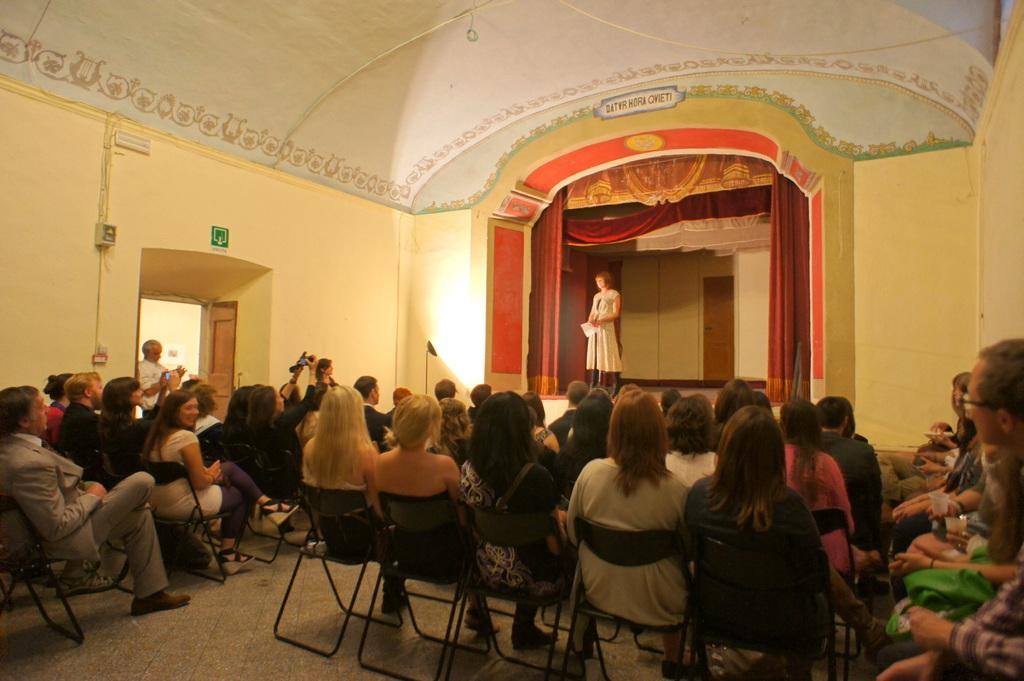What are the people in the image doing? There are many persons sitting on chairs, suggesting they are attending an event or gathering. What is happening on the stage? A lady is standing on the stage, possibly performing or addressing the audience. What is the purpose of the curtain on the stage? The curtain on the stage may be used for theatrical purposes, such as revealing or hiding performers or props. How can people enter the area where the chairs are located? There is an entrance on the left side, which people can use to enter the area. What can be seen on the walls in the image? There are pipes on the walls, which may be part of the building's infrastructure or for ventilation purposes. How much money is being thrown in the air by the lady on the stage? There is no indication in the image that the lady on the stage is throwing money or any other objects in the air. What type of shoe is the lady on the stage wearing? There is no visible shoe on the lady's foot in the image. 